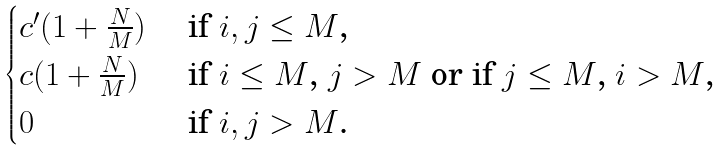Convert formula to latex. <formula><loc_0><loc_0><loc_500><loc_500>\begin{cases} c ^ { \prime } ( 1 + \frac { N } { M } ) & \text { if $i,j \leq M$,} \\ c ( 1 + \frac { N } { M } ) & \text { if $i \leq M$, $j>M$ or if $j\leq M$, $i>M$,} \\ 0 & \text { if $i,j > M$.} \end{cases}</formula> 